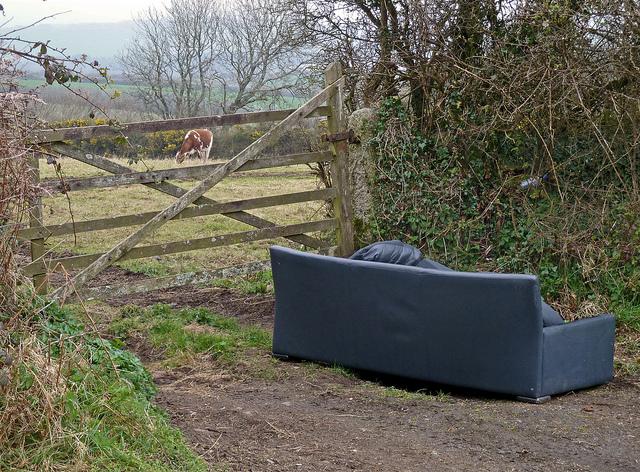Would a person be in danger of large mammal attacks here?
Be succinct. Yes. What material is the bench made out of?
Write a very short answer. Leather. Does there appear to be mountains in the background of this scene?
Write a very short answer. Yes. What is in front of the tree that you sit on?
Quick response, please. Couch. What animal is that?
Be succinct. Cow. What has been abandoned here?
Concise answer only. Couch. What color is the chair?
Be succinct. Blue. Why is the railing there?
Keep it brief. Cows. What is in the picture that someone could sit on?
Quick response, please. Couch. Is someone sitting on that sofa?
Give a very brief answer. No. Why aren't there any kids playing?
Short answer required. Pasture. Where would you rest in this photo?
Keep it brief. Couch. What is the bench in the picture made of?
Be succinct. Cloth. 